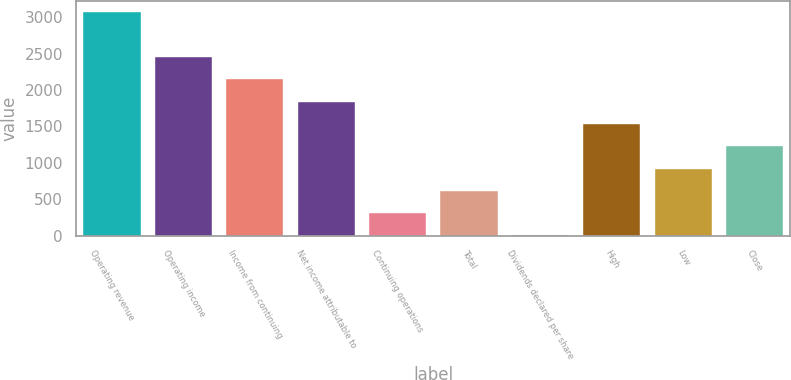Convert chart. <chart><loc_0><loc_0><loc_500><loc_500><bar_chart><fcel>Operating revenue<fcel>Operating income<fcel>Income from continuing<fcel>Net income attributable to<fcel>Continuing operations<fcel>Total<fcel>Dividends declared per share<fcel>High<fcel>Low<fcel>Close<nl><fcel>3069<fcel>2455.28<fcel>2148.41<fcel>1841.54<fcel>307.19<fcel>614.06<fcel>0.32<fcel>1534.67<fcel>920.93<fcel>1227.8<nl></chart> 